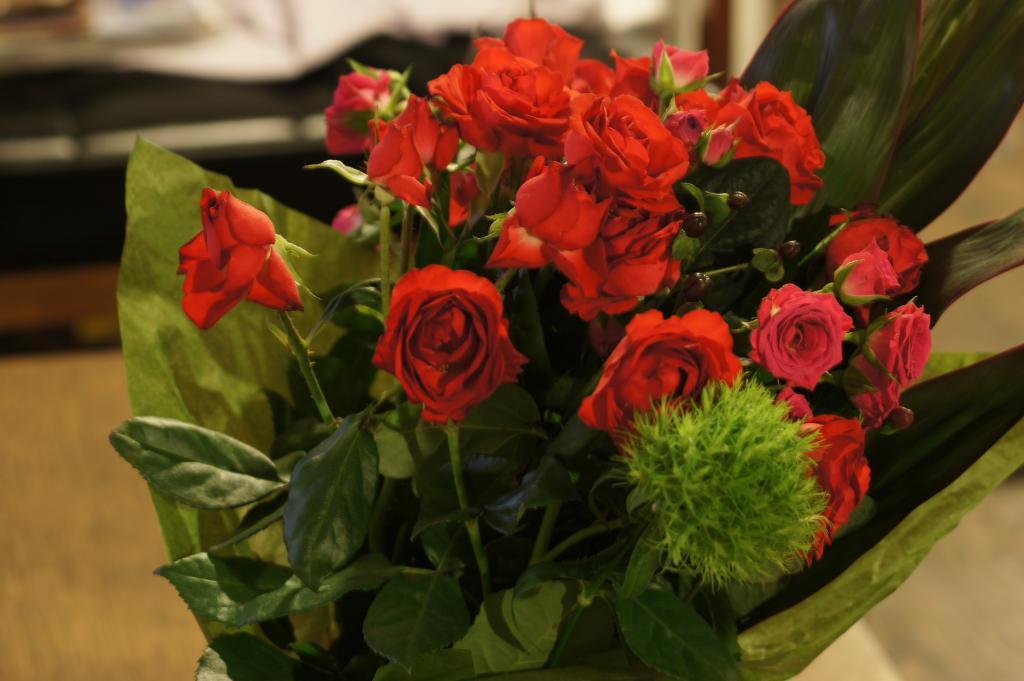Could you give a brief overview of what you see in this image? In this image I can see few red color roses and few green leaves. Background is blurred. 